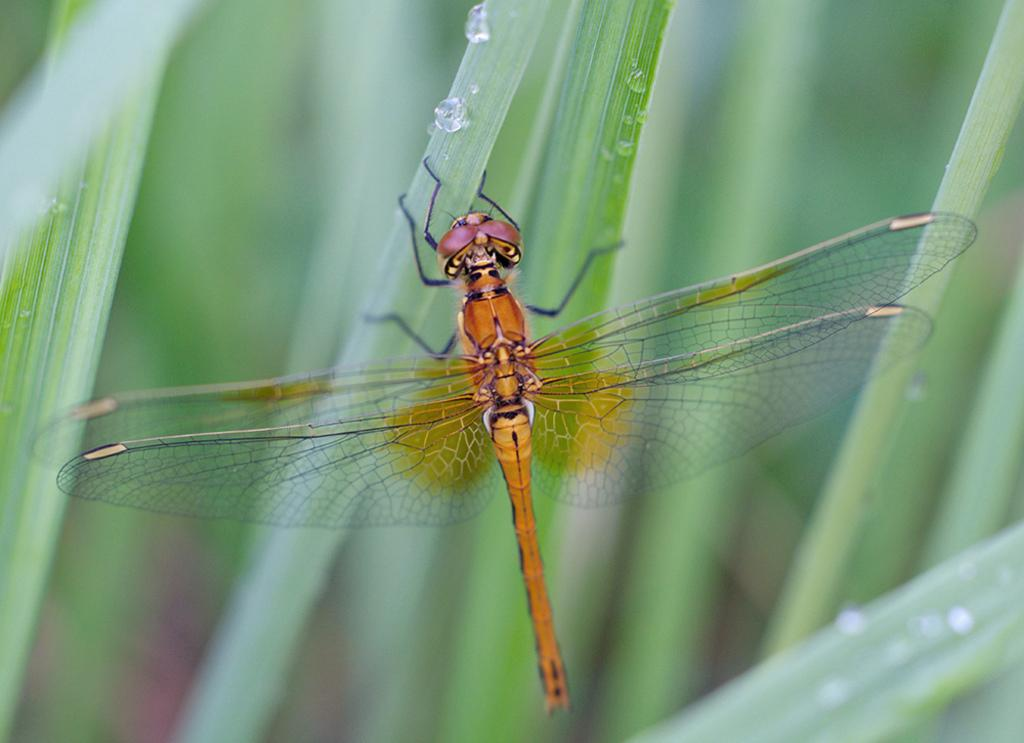What insect can be seen in the picture? There is a dragonfly in the picture. What can be seen in the background of the picture? There are plants in the background of the picture. What is present on the leaves of the plants? Water droplets are visible on the leaves of the plants. What type of crib is visible in the picture? There is no crib present in the picture; it features a dragonfly and plants with water droplets on the leaves. 